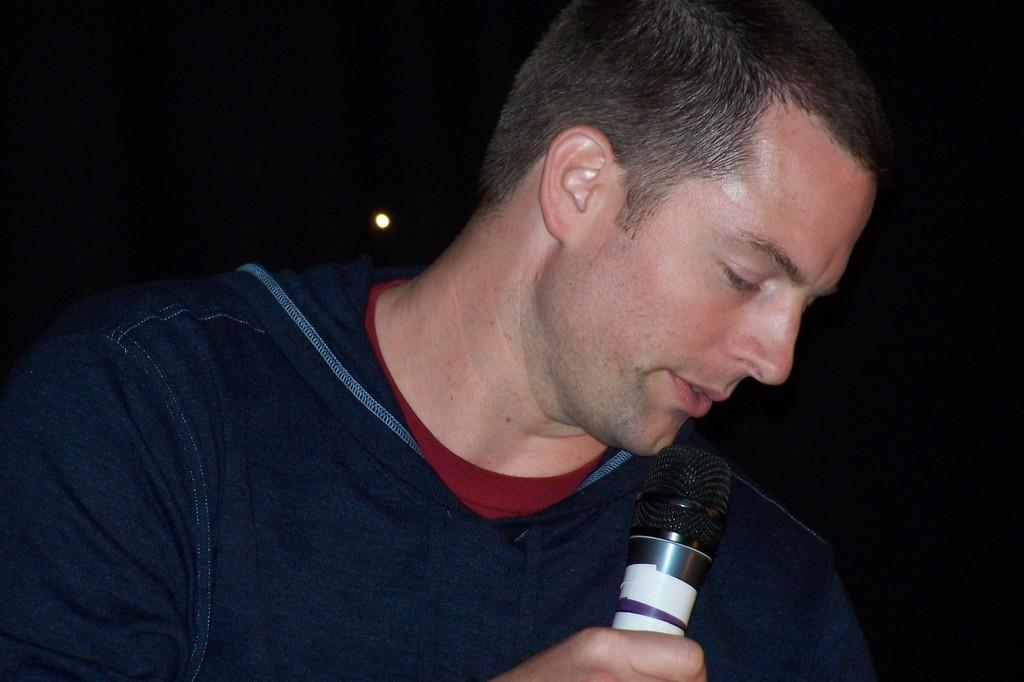Who is the main subject in the image? There is a man in the image. What is the man wearing? The man is wearing a t-shirt. What object is the man holding in his right hand? The man is holding a microphone in his right hand. What is the man doing in the image? The man is talking. Can you see any roses in the image? There are no roses present in the image. What type of curve is the man's speech following in the image? The image does not provide information about the man's speech pattern or any curves related to it. 